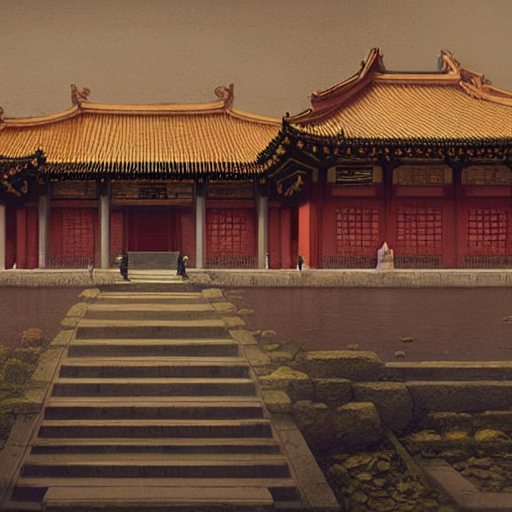What could this place represent culturally or historically? This image is evocative of a temple or palace compound that might be found in historical China, possibly representing a place of significant cultural and historical importance. Buildings like these were often centers of religious worship, imperial governance, or cultural celebration. Their design not only reflects aesthetic choices but also cultural values such as respect for hierarchy and the importance of ritual and ceremony. 